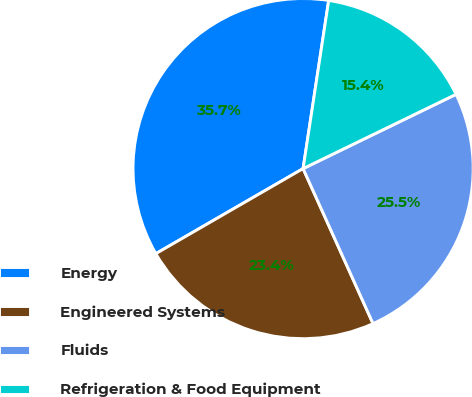<chart> <loc_0><loc_0><loc_500><loc_500><pie_chart><fcel>Energy<fcel>Engineered Systems<fcel>Fluids<fcel>Refrigeration & Food Equipment<nl><fcel>35.74%<fcel>23.41%<fcel>25.45%<fcel>15.4%<nl></chart> 